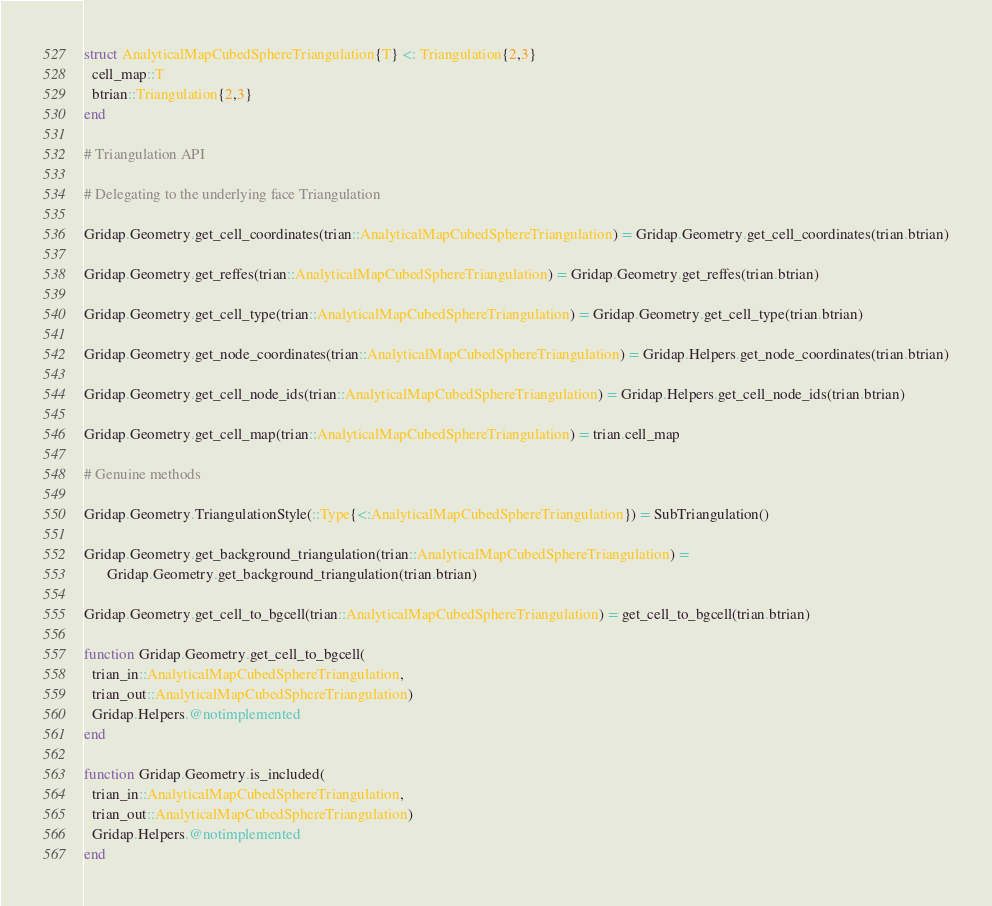<code> <loc_0><loc_0><loc_500><loc_500><_Julia_>
struct AnalyticalMapCubedSphereTriangulation{T} <: Triangulation{2,3}
  cell_map::T
  btrian::Triangulation{2,3}
end

# Triangulation API

# Delegating to the underlying face Triangulation

Gridap.Geometry.get_cell_coordinates(trian::AnalyticalMapCubedSphereTriangulation) = Gridap.Geometry.get_cell_coordinates(trian.btrian)

Gridap.Geometry.get_reffes(trian::AnalyticalMapCubedSphereTriangulation) = Gridap.Geometry.get_reffes(trian.btrian)

Gridap.Geometry.get_cell_type(trian::AnalyticalMapCubedSphereTriangulation) = Gridap.Geometry.get_cell_type(trian.btrian)

Gridap.Geometry.get_node_coordinates(trian::AnalyticalMapCubedSphereTriangulation) = Gridap.Helpers.get_node_coordinates(trian.btrian)

Gridap.Geometry.get_cell_node_ids(trian::AnalyticalMapCubedSphereTriangulation) = Gridap.Helpers.get_cell_node_ids(trian.btrian)

Gridap.Geometry.get_cell_map(trian::AnalyticalMapCubedSphereTriangulation) = trian.cell_map

# Genuine methods

Gridap.Geometry.TriangulationStyle(::Type{<:AnalyticalMapCubedSphereTriangulation}) = SubTriangulation()

Gridap.Geometry.get_background_triangulation(trian::AnalyticalMapCubedSphereTriangulation) =
      Gridap.Geometry.get_background_triangulation(trian.btrian)

Gridap.Geometry.get_cell_to_bgcell(trian::AnalyticalMapCubedSphereTriangulation) = get_cell_to_bgcell(trian.btrian)

function Gridap.Geometry.get_cell_to_bgcell(
  trian_in::AnalyticalMapCubedSphereTriangulation,
  trian_out::AnalyticalMapCubedSphereTriangulation)
  Gridap.Helpers.@notimplemented
end

function Gridap.Geometry.is_included(
  trian_in::AnalyticalMapCubedSphereTriangulation,
  trian_out::AnalyticalMapCubedSphereTriangulation)
  Gridap.Helpers.@notimplemented
end
</code> 